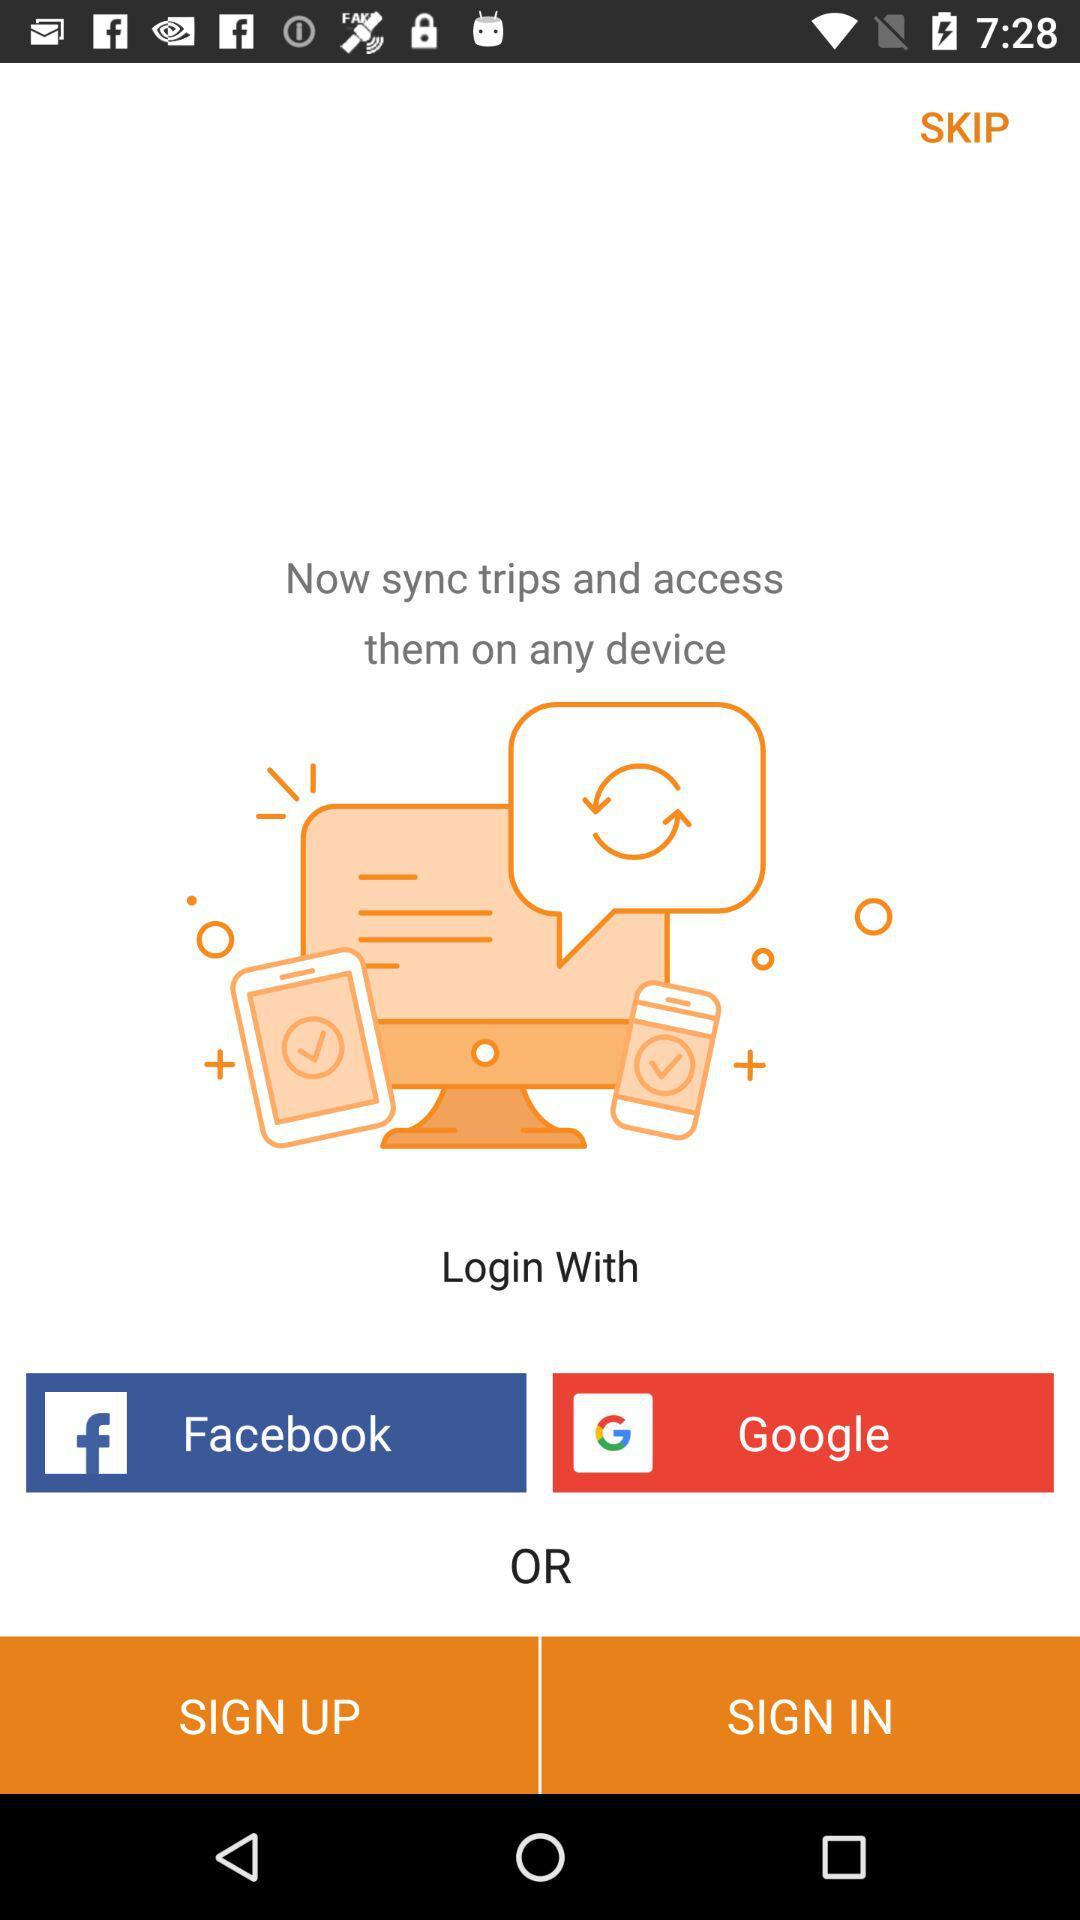What accounts can I use to login? You can login with "Facebook" and "Google". 